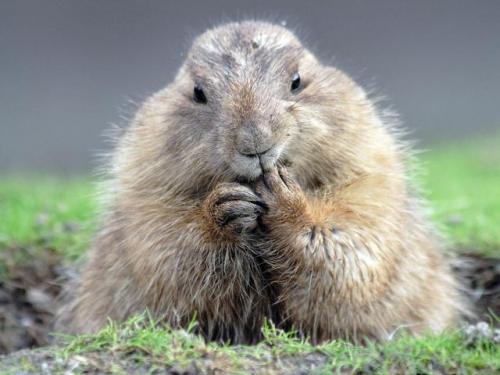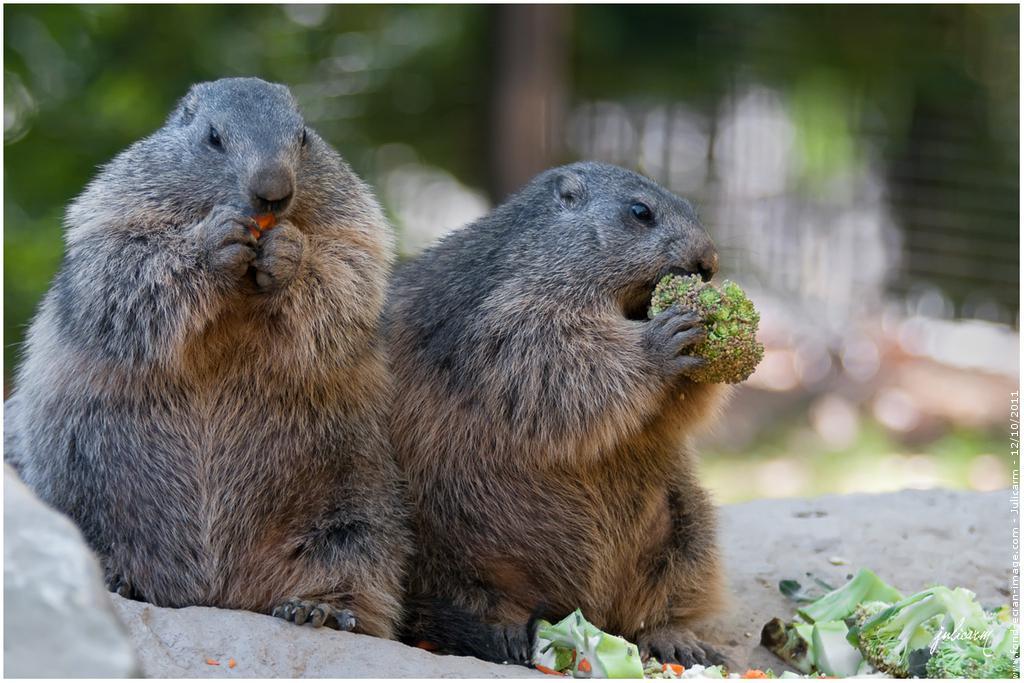The first image is the image on the left, the second image is the image on the right. Given the left and right images, does the statement "The animal in the image on the right is holding orange food." hold true? Answer yes or no. No. The first image is the image on the left, the second image is the image on the right. Assess this claim about the two images: "Two animals are eating in the image on the right.". Correct or not? Answer yes or no. Yes. The first image is the image on the left, the second image is the image on the right. For the images displayed, is the sentence "Right image shows two upright marmots with hands clasping something." factually correct? Answer yes or no. Yes. 